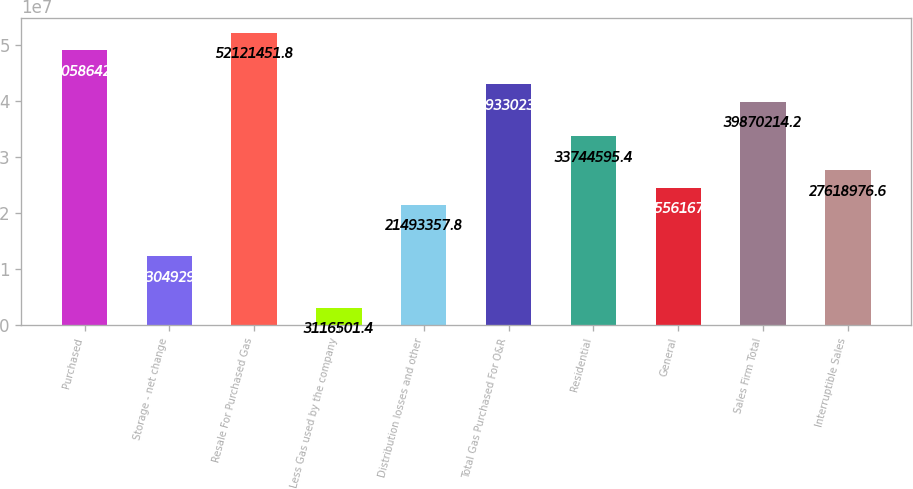<chart> <loc_0><loc_0><loc_500><loc_500><bar_chart><fcel>Purchased<fcel>Storage - net change<fcel>Resale For Purchased Gas<fcel>Less Gas used by the company<fcel>Distribution losses and other<fcel>Total Gas Purchased For O&R<fcel>Residential<fcel>General<fcel>Sales Firm Total<fcel>Interruptible Sales<nl><fcel>4.90586e+07<fcel>1.23049e+07<fcel>5.21215e+07<fcel>3.1165e+06<fcel>2.14934e+07<fcel>4.2933e+07<fcel>3.37446e+07<fcel>2.45562e+07<fcel>3.98702e+07<fcel>2.7619e+07<nl></chart> 